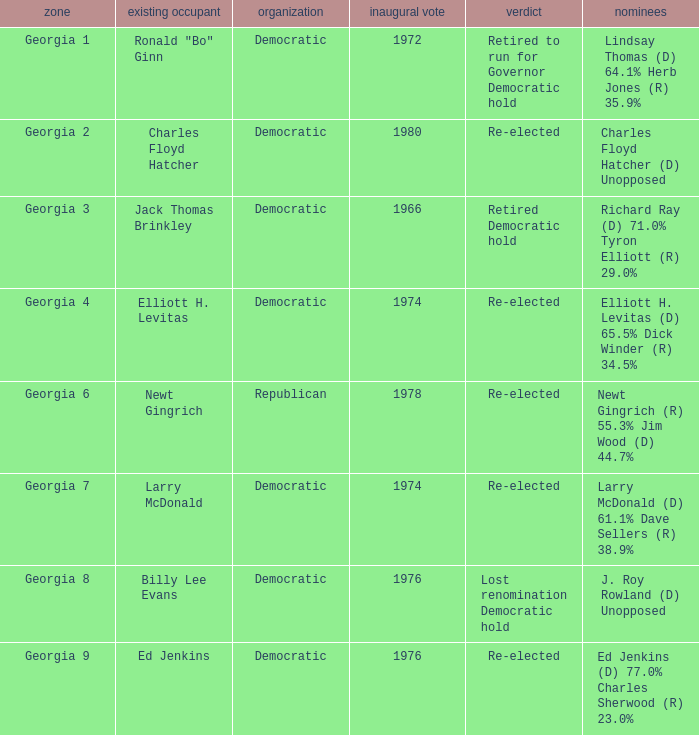Name the candidates for georgia 8 J. Roy Rowland (D) Unopposed. 